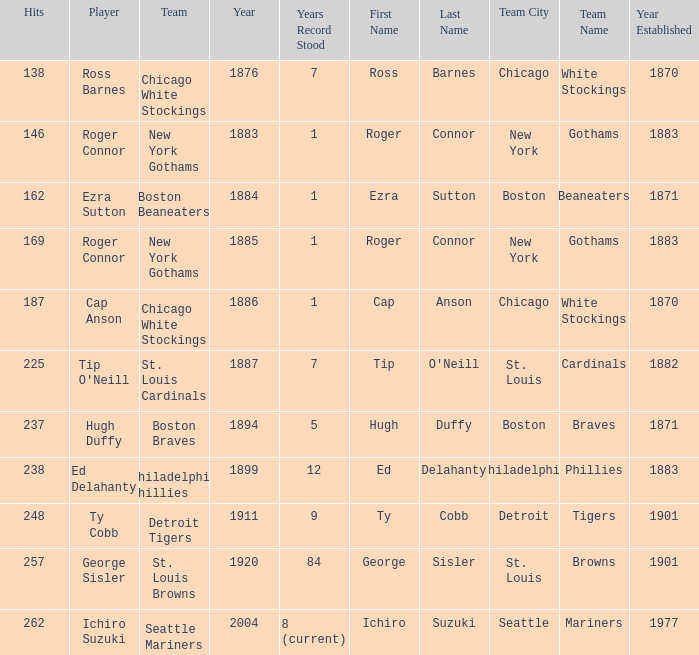Name the least hits for year less than 1920 and player of ed delahanty 238.0. 